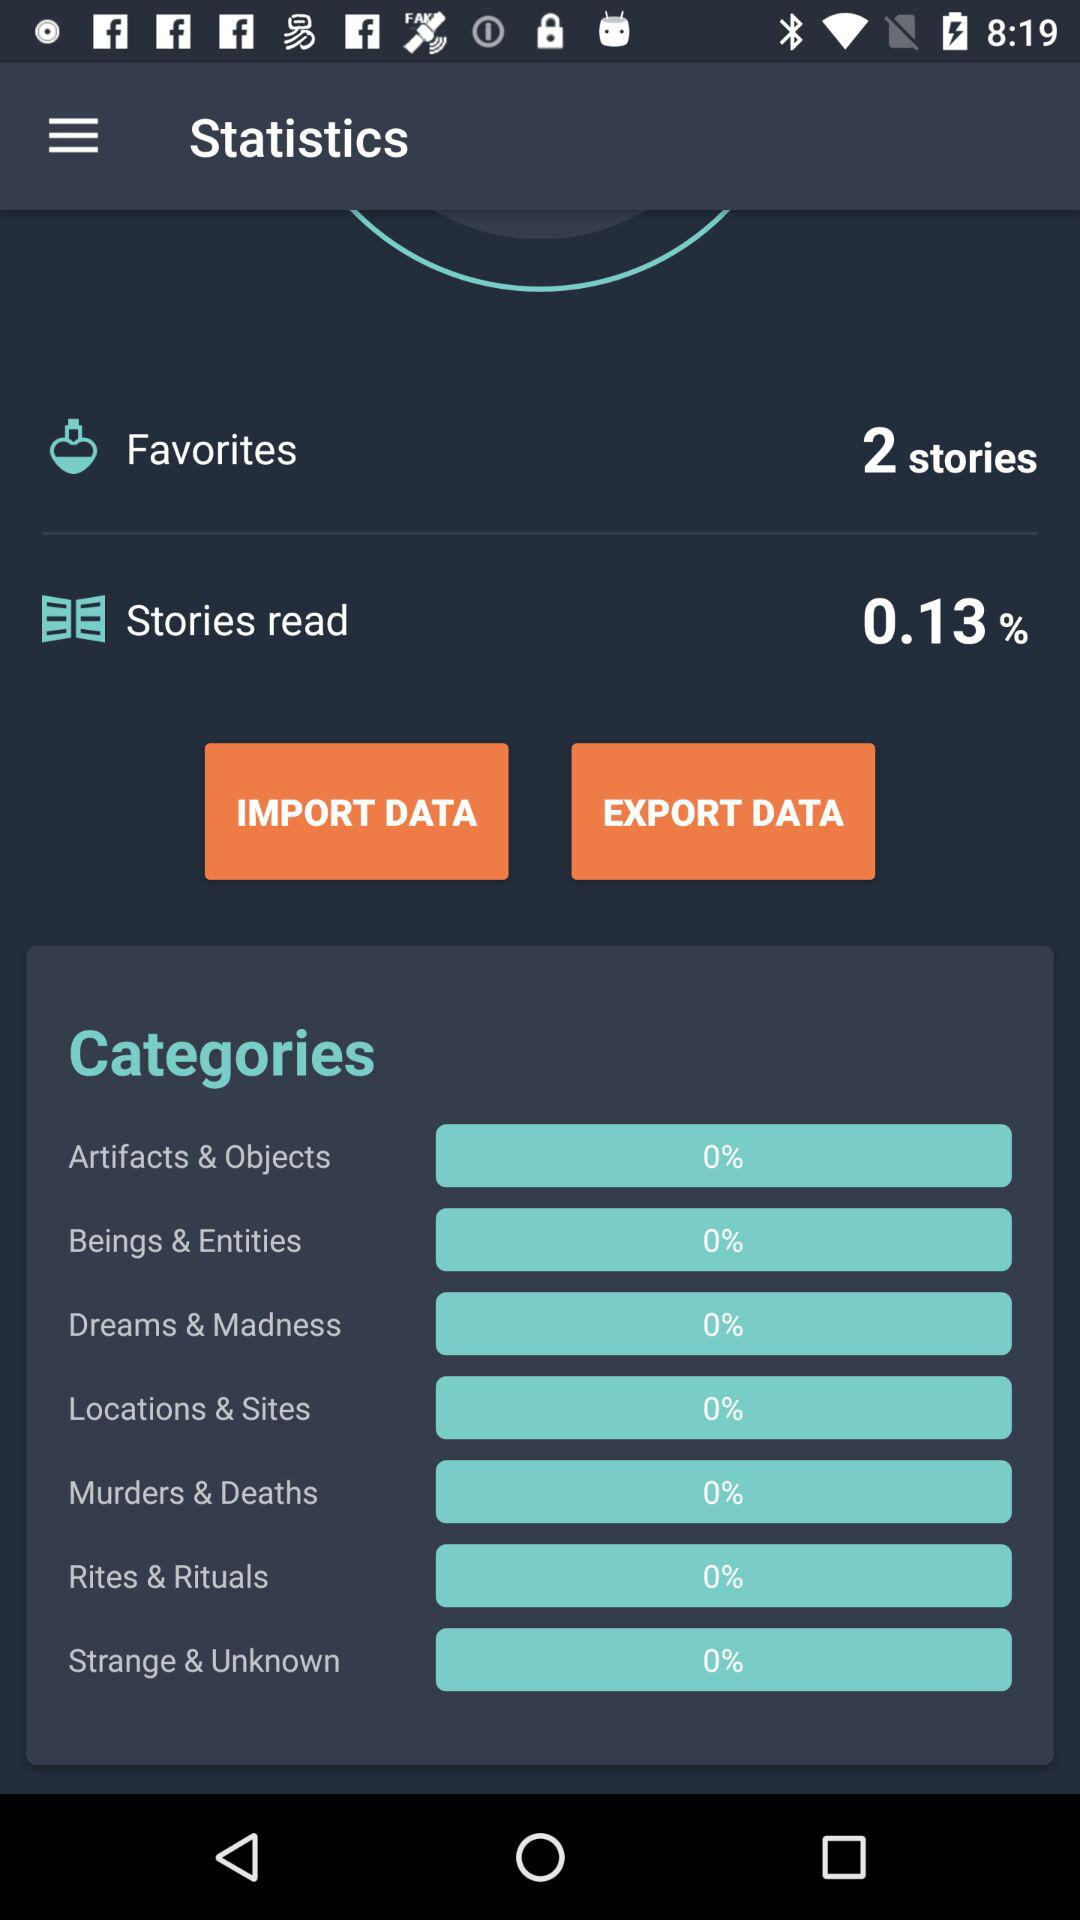What is the percentage of "Locations & Sites"? The percentage is 0. 